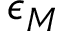<formula> <loc_0><loc_0><loc_500><loc_500>\epsilon _ { M }</formula> 